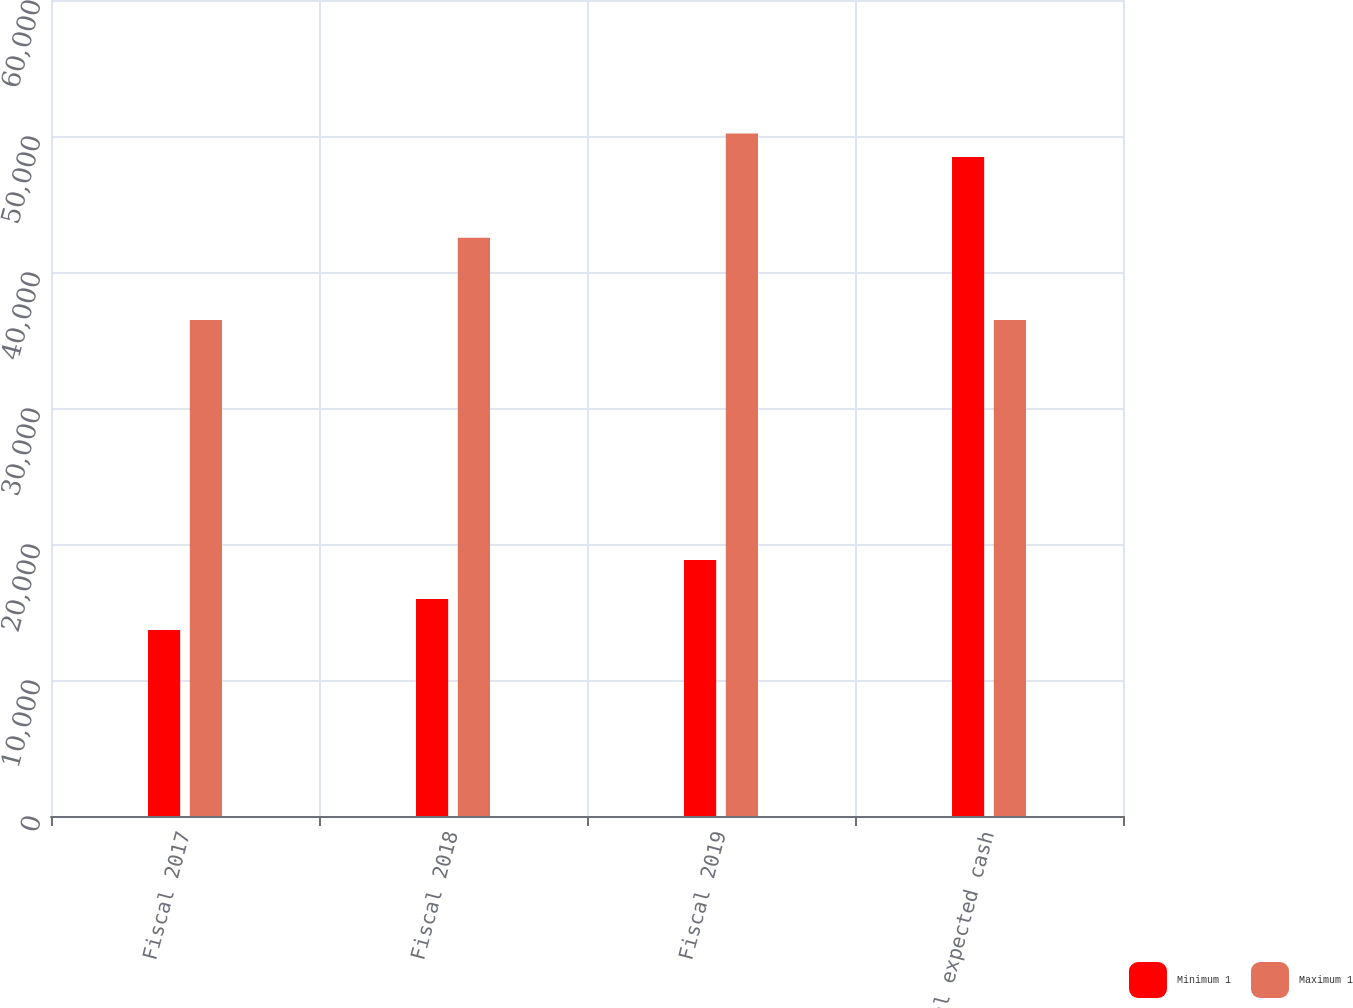Convert chart to OTSL. <chart><loc_0><loc_0><loc_500><loc_500><stacked_bar_chart><ecel><fcel>Fiscal 2017<fcel>Fiscal 2018<fcel>Fiscal 2019<fcel>Total expected cash<nl><fcel>Minimum 1<fcel>13679<fcel>15947<fcel>18822<fcel>48448<nl><fcel>Maximum 1<fcel>36477<fcel>42524<fcel>50193<fcel>36477<nl></chart> 